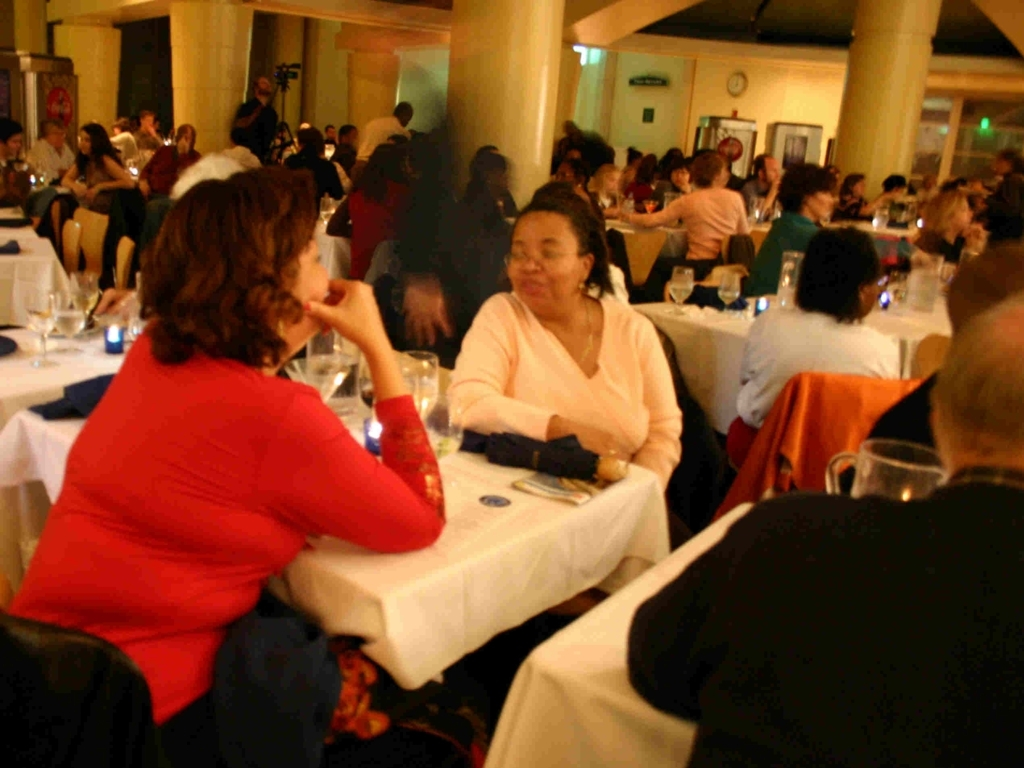What can we infer about the lighting and the time of day? The lighting appears to be artificial, likely coming from ceiling fixtures, which suggests the event is taking place indoors during the evening. This is reinforced by the warm glow that casts soft shadows, creating an intimate ambiance typical of nighttime events. 